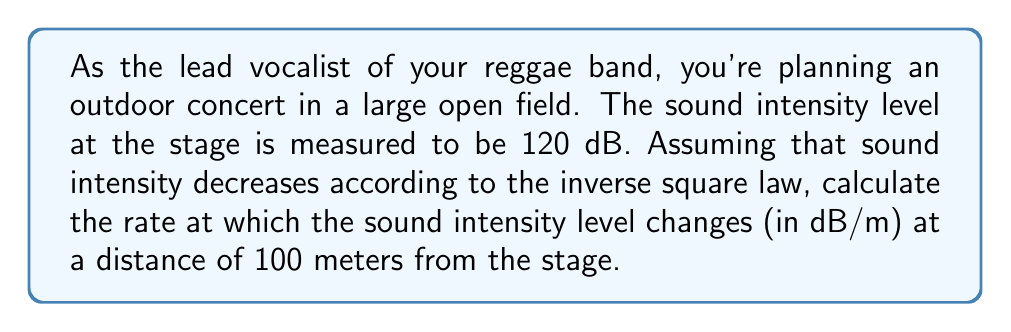Could you help me with this problem? To solve this problem, we'll follow these steps:

1) First, recall the inverse square law for sound intensity:

   $$ I = \frac{I_0}{r^2} $$

   where $I$ is the intensity at distance $r$, and $I_0$ is the intensity at the source.

2) The relationship between sound intensity level (L) in dB and intensity (I) is:

   $$ L = 10 \log_{10}\left(\frac{I}{I_{ref}}\right) $$

   where $I_{ref}$ is the reference intensity, usually taken as $10^{-12}$ W/m².

3) We're interested in how L changes with r. To find this, we need to differentiate L with respect to r:

   $$ \frac{dL}{dr} = \frac{d}{dr}\left[10 \log_{10}\left(\frac{I}{I_{ref}}\right)\right] $$

4) Substituting the inverse square law:

   $$ \frac{dL}{dr} = \frac{d}{dr}\left[10 \log_{10}\left(\frac{I_0}{r^2I_{ref}}\right)\right] $$

5) Using the chain rule:

   $$ \frac{dL}{dr} = 10 \cdot \frac{1}{\ln(10)} \cdot \frac{d}{dr}\left[\ln\left(\frac{I_0}{r^2I_{ref}}\right)\right] $$

6) Simplifying:

   $$ \frac{dL}{dr} = 10 \cdot \frac{1}{\ln(10)} \cdot \frac{d}{dr}\left[\ln(I_0) - \ln(I_{ref}) - 2\ln(r)\right] $$

7) The only term dependent on r is $-2\ln(r)$, so:

   $$ \frac{dL}{dr} = 10 \cdot \frac{1}{\ln(10)} \cdot \left(-\frac{2}{r}\right) = -\frac{20}{r\ln(10)} $$

8) At r = 100 m:

   $$ \frac{dL}{dr}\Big|_{r=100} = -\frac{20}{100\ln(10)} \approx -0.0868 \text{ dB/m} $$
Answer: $-0.0868 \text{ dB/m}$ 